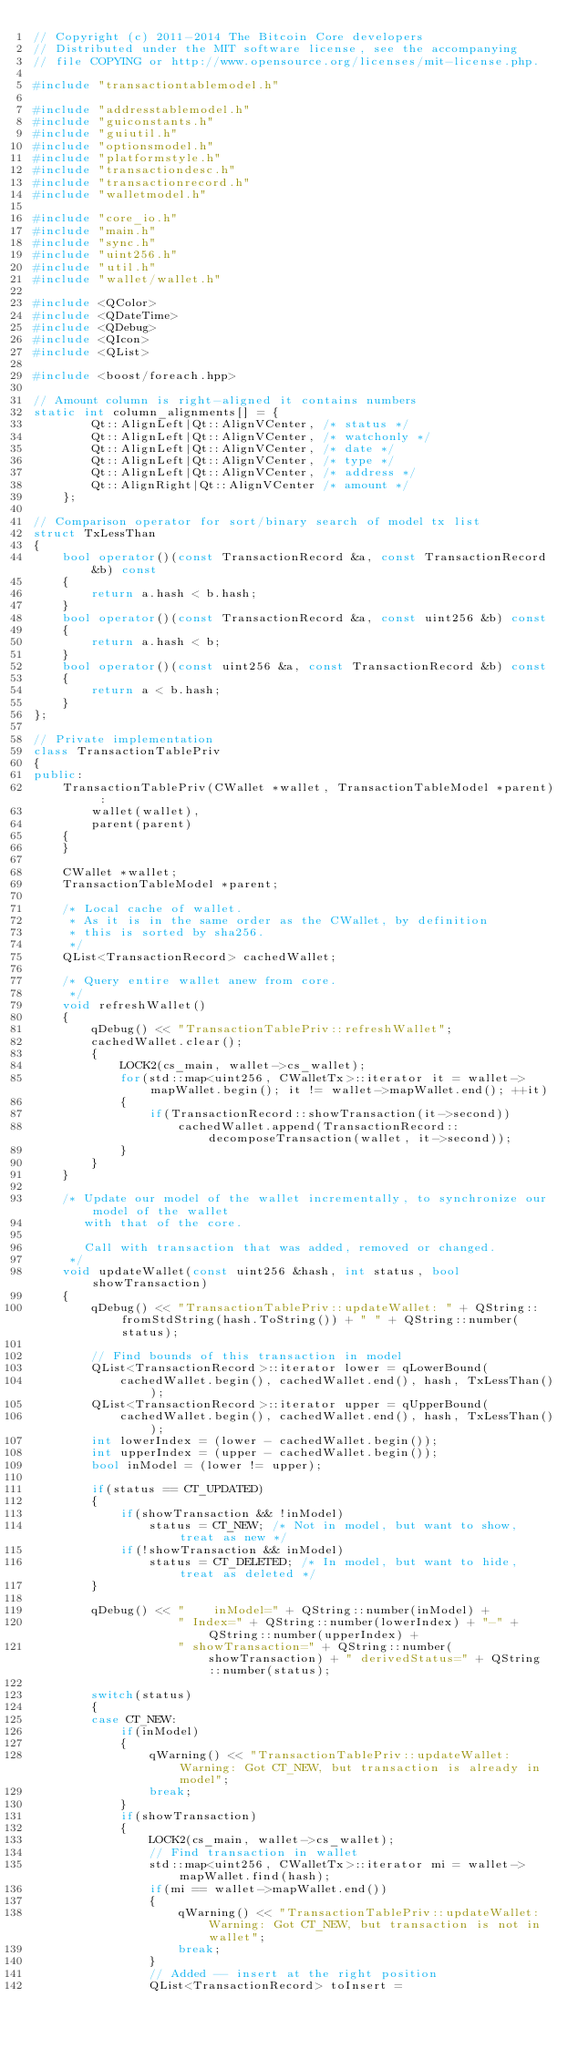<code> <loc_0><loc_0><loc_500><loc_500><_C++_>// Copyright (c) 2011-2014 The Bitcoin Core developers
// Distributed under the MIT software license, see the accompanying
// file COPYING or http://www.opensource.org/licenses/mit-license.php.

#include "transactiontablemodel.h"

#include "addresstablemodel.h"
#include "guiconstants.h"
#include "guiutil.h"
#include "optionsmodel.h"
#include "platformstyle.h"
#include "transactiondesc.h"
#include "transactionrecord.h"
#include "walletmodel.h"

#include "core_io.h"
#include "main.h"
#include "sync.h"
#include "uint256.h"
#include "util.h"
#include "wallet/wallet.h"

#include <QColor>
#include <QDateTime>
#include <QDebug>
#include <QIcon>
#include <QList>

#include <boost/foreach.hpp>

// Amount column is right-aligned it contains numbers
static int column_alignments[] = {
        Qt::AlignLeft|Qt::AlignVCenter, /* status */
        Qt::AlignLeft|Qt::AlignVCenter, /* watchonly */
        Qt::AlignLeft|Qt::AlignVCenter, /* date */
        Qt::AlignLeft|Qt::AlignVCenter, /* type */
        Qt::AlignLeft|Qt::AlignVCenter, /* address */
        Qt::AlignRight|Qt::AlignVCenter /* amount */
    };

// Comparison operator for sort/binary search of model tx list
struct TxLessThan
{
    bool operator()(const TransactionRecord &a, const TransactionRecord &b) const
    {
        return a.hash < b.hash;
    }
    bool operator()(const TransactionRecord &a, const uint256 &b) const
    {
        return a.hash < b;
    }
    bool operator()(const uint256 &a, const TransactionRecord &b) const
    {
        return a < b.hash;
    }
};

// Private implementation
class TransactionTablePriv
{
public:
    TransactionTablePriv(CWallet *wallet, TransactionTableModel *parent) :
        wallet(wallet),
        parent(parent)
    {
    }

    CWallet *wallet;
    TransactionTableModel *parent;

    /* Local cache of wallet.
     * As it is in the same order as the CWallet, by definition
     * this is sorted by sha256.
     */
    QList<TransactionRecord> cachedWallet;

    /* Query entire wallet anew from core.
     */
    void refreshWallet()
    {
        qDebug() << "TransactionTablePriv::refreshWallet";
        cachedWallet.clear();
        {
            LOCK2(cs_main, wallet->cs_wallet);
            for(std::map<uint256, CWalletTx>::iterator it = wallet->mapWallet.begin(); it != wallet->mapWallet.end(); ++it)
            {
                if(TransactionRecord::showTransaction(it->second))
                    cachedWallet.append(TransactionRecord::decomposeTransaction(wallet, it->second));
            }
        }
    }

    /* Update our model of the wallet incrementally, to synchronize our model of the wallet
       with that of the core.

       Call with transaction that was added, removed or changed.
     */
    void updateWallet(const uint256 &hash, int status, bool showTransaction)
    {
        qDebug() << "TransactionTablePriv::updateWallet: " + QString::fromStdString(hash.ToString()) + " " + QString::number(status);

        // Find bounds of this transaction in model
        QList<TransactionRecord>::iterator lower = qLowerBound(
            cachedWallet.begin(), cachedWallet.end(), hash, TxLessThan());
        QList<TransactionRecord>::iterator upper = qUpperBound(
            cachedWallet.begin(), cachedWallet.end(), hash, TxLessThan());
        int lowerIndex = (lower - cachedWallet.begin());
        int upperIndex = (upper - cachedWallet.begin());
        bool inModel = (lower != upper);

        if(status == CT_UPDATED)
        {
            if(showTransaction && !inModel)
                status = CT_NEW; /* Not in model, but want to show, treat as new */
            if(!showTransaction && inModel)
                status = CT_DELETED; /* In model, but want to hide, treat as deleted */
        }

        qDebug() << "    inModel=" + QString::number(inModel) +
                    " Index=" + QString::number(lowerIndex) + "-" + QString::number(upperIndex) +
                    " showTransaction=" + QString::number(showTransaction) + " derivedStatus=" + QString::number(status);

        switch(status)
        {
        case CT_NEW:
            if(inModel)
            {
                qWarning() << "TransactionTablePriv::updateWallet: Warning: Got CT_NEW, but transaction is already in model";
                break;
            }
            if(showTransaction)
            {
                LOCK2(cs_main, wallet->cs_wallet);
                // Find transaction in wallet
                std::map<uint256, CWalletTx>::iterator mi = wallet->mapWallet.find(hash);
                if(mi == wallet->mapWallet.end())
                {
                    qWarning() << "TransactionTablePriv::updateWallet: Warning: Got CT_NEW, but transaction is not in wallet";
                    break;
                }
                // Added -- insert at the right position
                QList<TransactionRecord> toInsert =</code> 